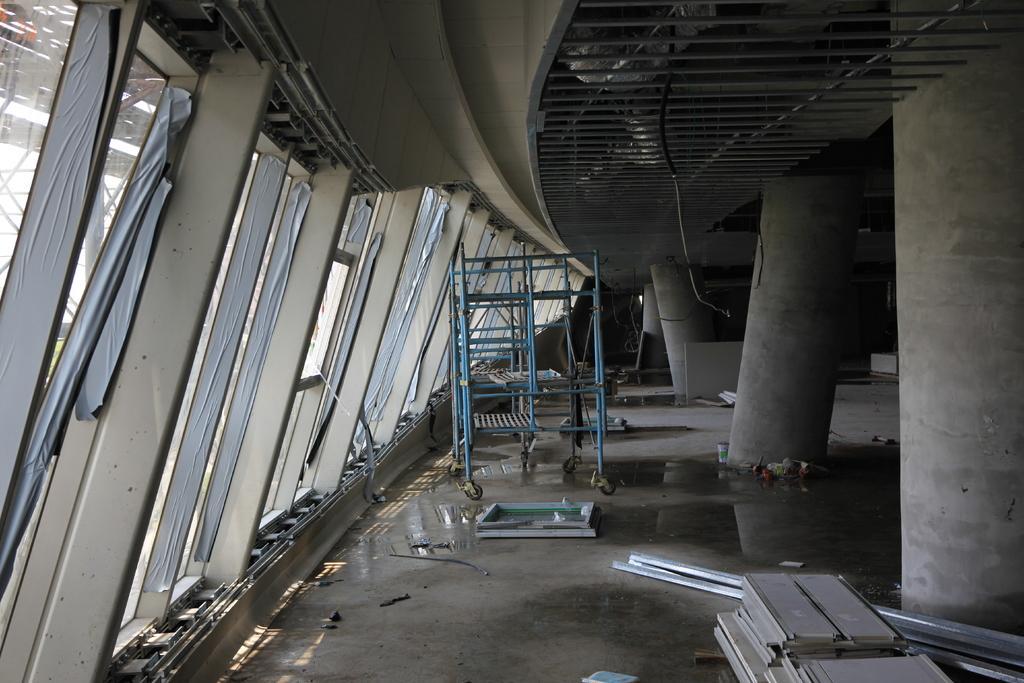Please provide a concise description of this image. In this image I can see pillars, rooftop, metal rods, wheel stand and so on. This image is taken may be during a day. 